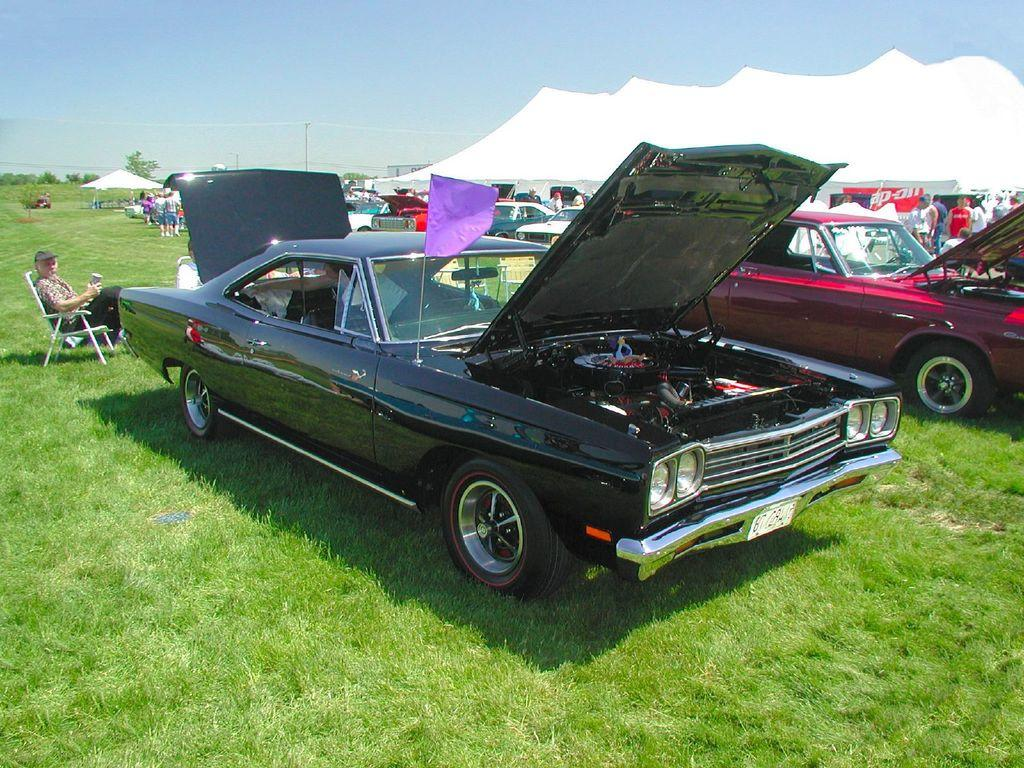What types of objects are present in the image? There are vehicles, a flag, a tent, an umbrella, and a pole in the image. What can be seen on the ground in the image? There are people on the ground in the image. Can you describe the position of a person in the image? There is a person sitting on a chair in the image. What is the natural environment visible in the image? There are trees in the image, and the sky is visible in the background. What is the name of the person on the list in the image? There is no list present in the image, so it is not possible to answer that question. How many legs does the car have in the image? Cars do not have legs; they have wheels. In the image, the vehicles have wheels, not legs. 